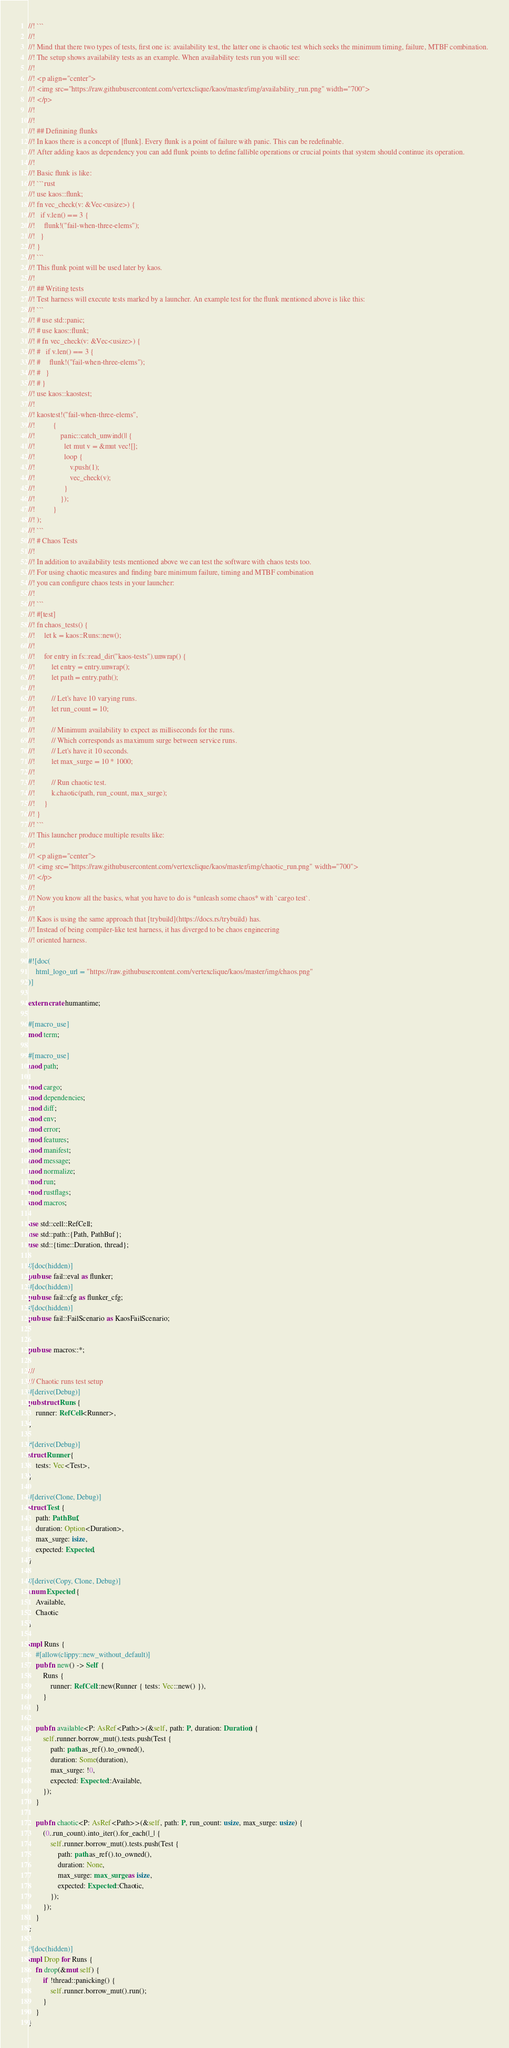<code> <loc_0><loc_0><loc_500><loc_500><_Rust_>//! ```
//!
//! Mind that there two types of tests, first one is: availability test, the latter one is chaotic test which seeks the minimum timing, failure, MTBF combination.
//! The setup shows availability tests as an example. When availability tests run you will see:
//!
//! <p align="center">
//! <img src="https://raw.githubusercontent.com/vertexclique/kaos/master/img/availability_run.png" width="700">
//! </p>
//!
//!
//! ## Definining flunks
//! In kaos there is a concept of [flunk]. Every flunk is a point of failure with panic. This can be redefinable.
//! After adding kaos as dependency you can add flunk points to define fallible operations or crucial points that system should continue its operation.
//!
//! Basic flunk is like:
//! ```rust
//! use kaos::flunk;
//! fn vec_check(v: &Vec<usize>) {
//!   if v.len() == 3 {
//!     flunk!("fail-when-three-elems");
//!   }
//! }
//! ```
//! This flunk point will be used later by kaos.
//!
//! ## Writing tests
//! Test harness will execute tests marked by a launcher. An example test for the flunk mentioned above is like this:
//! ```
//! # use std::panic;
//! # use kaos::flunk;
//! # fn vec_check(v: &Vec<usize>) {
//! #   if v.len() == 3 {
//! #     flunk!("fail-when-three-elems");
//! #   }
//! # }
//! use kaos::kaostest;
//!
//! kaostest!("fail-when-three-elems",
//!          {
//!              panic::catch_unwind(|| {
//!                let mut v = &mut vec![];
//!                loop {
//!                   v.push(1);
//!                   vec_check(v);
//!                }
//!              });
//!          }
//! );
//! ```
//! # Chaos Tests
//!
//! In addition to availability tests mentioned above we can test the software with chaos tests too.
//! For using chaotic measures and finding bare minimum failure, timing and MTBF combination
//! you can configure chaos tests in your launcher:
//!
//! ```
//! #[test]
//! fn chaos_tests() {
//!     let k = kaos::Runs::new();
//!
//!     for entry in fs::read_dir("kaos-tests").unwrap() {
//!         let entry = entry.unwrap();
//!         let path = entry.path();
//!
//!         // Let's have 10 varying runs.
//!         let run_count = 10;
//!
//!         // Minimum availability to expect as milliseconds for the runs.
//!         // Which corresponds as maximum surge between service runs.
//!         // Let's have it 10 seconds.
//!         let max_surge = 10 * 1000;
//!
//!         // Run chaotic test.
//!         k.chaotic(path, run_count, max_surge);
//!     }
//! }
//! ```
//! This launcher produce multiple results like:
//!
//! <p align="center">
//! <img src="https://raw.githubusercontent.com/vertexclique/kaos/master/img/chaotic_run.png" width="700">
//! </p>
//!
//! Now you know all the basics, what you have to do is *unleash some chaos* with `cargo test`.
//!
//! Kaos is using the same approach that [trybuild](https://docs.rs/trybuild) has.
//! Instead of being compiler-like test harness, it has diverged to be chaos engineering
//! oriented harness.

#![doc(
    html_logo_url = "https://raw.githubusercontent.com/vertexclique/kaos/master/img/chaos.png"
)]

extern crate humantime;

#[macro_use]
mod term;

#[macro_use]
mod path;

mod cargo;
mod dependencies;
mod diff;
mod env;
mod error;
mod features;
mod manifest;
mod message;
mod normalize;
mod run;
mod rustflags;
mod macros;

use std::cell::RefCell;
use std::path::{Path, PathBuf};
use std::{time::Duration, thread};

#[doc(hidden)]
pub use fail::eval as flunker;
#[doc(hidden)]
pub use fail::cfg as flunker_cfg;
#[doc(hidden)]
pub use fail::FailScenario as KaosFailScenario;


pub use macros::*;

///
/// Chaotic runs test setup
#[derive(Debug)]
pub struct Runs {
    runner: RefCell<Runner>,
}

#[derive(Debug)]
struct Runner {
    tests: Vec<Test>,
}

#[derive(Clone, Debug)]
struct Test {
    path: PathBuf,
    duration: Option<Duration>,
    max_surge: isize,
    expected: Expected,
}

#[derive(Copy, Clone, Debug)]
enum Expected {
    Available,
    Chaotic
}

impl Runs {
    #[allow(clippy::new_without_default)]
    pub fn new() -> Self {
        Runs {
            runner: RefCell::new(Runner { tests: Vec::new() }),
        }
    }

    pub fn available<P: AsRef<Path>>(&self, path: P, duration: Duration) {
        self.runner.borrow_mut().tests.push(Test {
            path: path.as_ref().to_owned(),
            duration: Some(duration),
            max_surge: !0,
            expected: Expected::Available,
        });
    }

    pub fn chaotic<P: AsRef<Path>>(&self, path: P, run_count: usize, max_surge: usize) {
        (0..run_count).into_iter().for_each(|_| {
            self.runner.borrow_mut().tests.push(Test {
                path: path.as_ref().to_owned(),
                duration: None,
                max_surge: max_surge as isize,
                expected: Expected::Chaotic,
            });
        });
    }
}

#[doc(hidden)]
impl Drop for Runs {
    fn drop(&mut self) {
        if !thread::panicking() {
            self.runner.borrow_mut().run();
        }
    }
}
</code> 